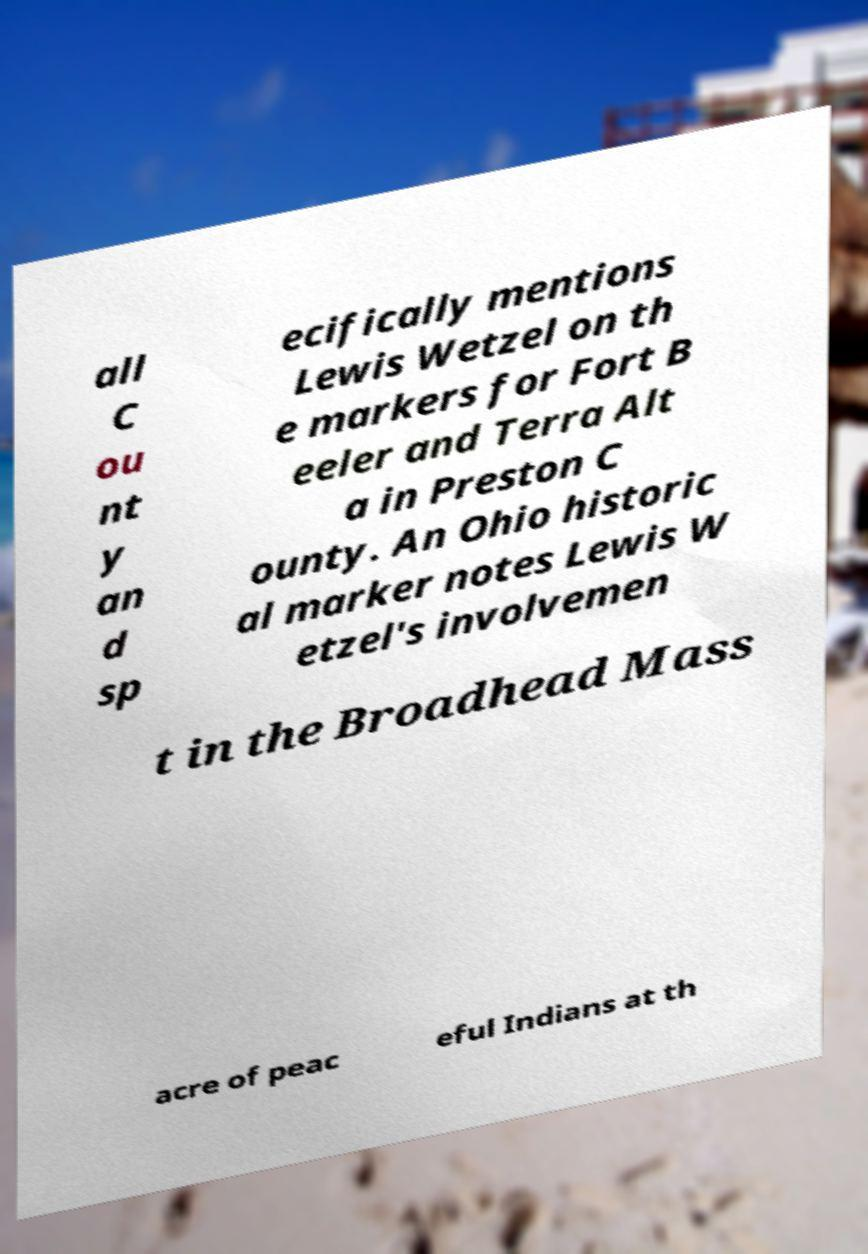Please read and relay the text visible in this image. What does it say? all C ou nt y an d sp ecifically mentions Lewis Wetzel on th e markers for Fort B eeler and Terra Alt a in Preston C ounty. An Ohio historic al marker notes Lewis W etzel's involvemen t in the Broadhead Mass acre of peac eful Indians at th 